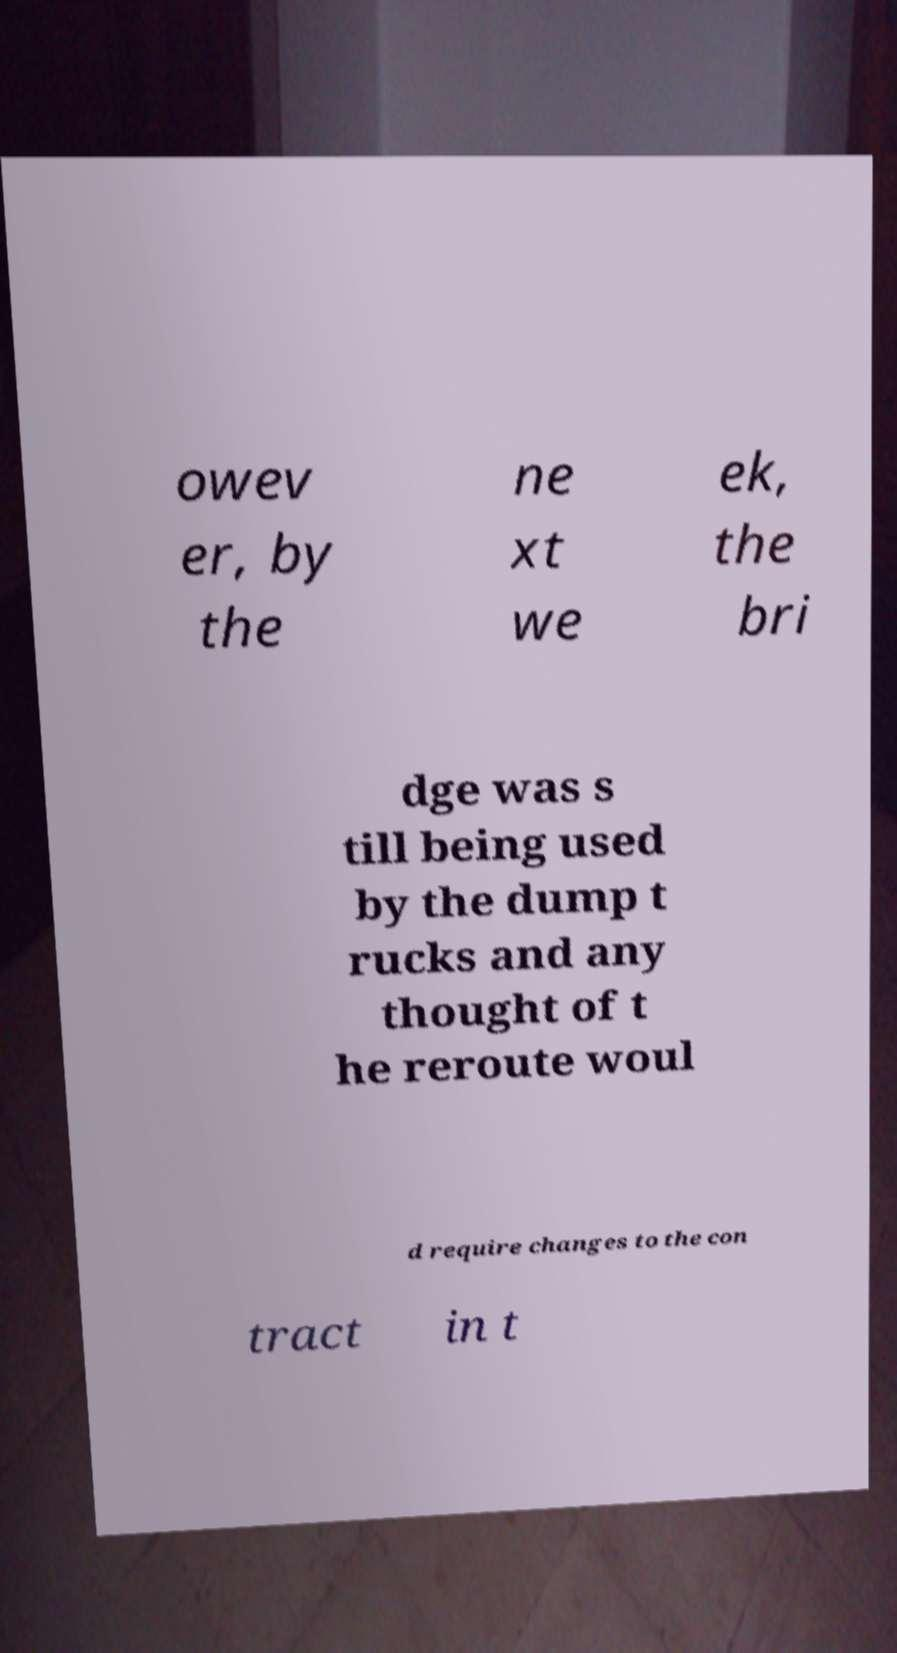Please read and relay the text visible in this image. What does it say? owev er, by the ne xt we ek, the bri dge was s till being used by the dump t rucks and any thought of t he reroute woul d require changes to the con tract in t 